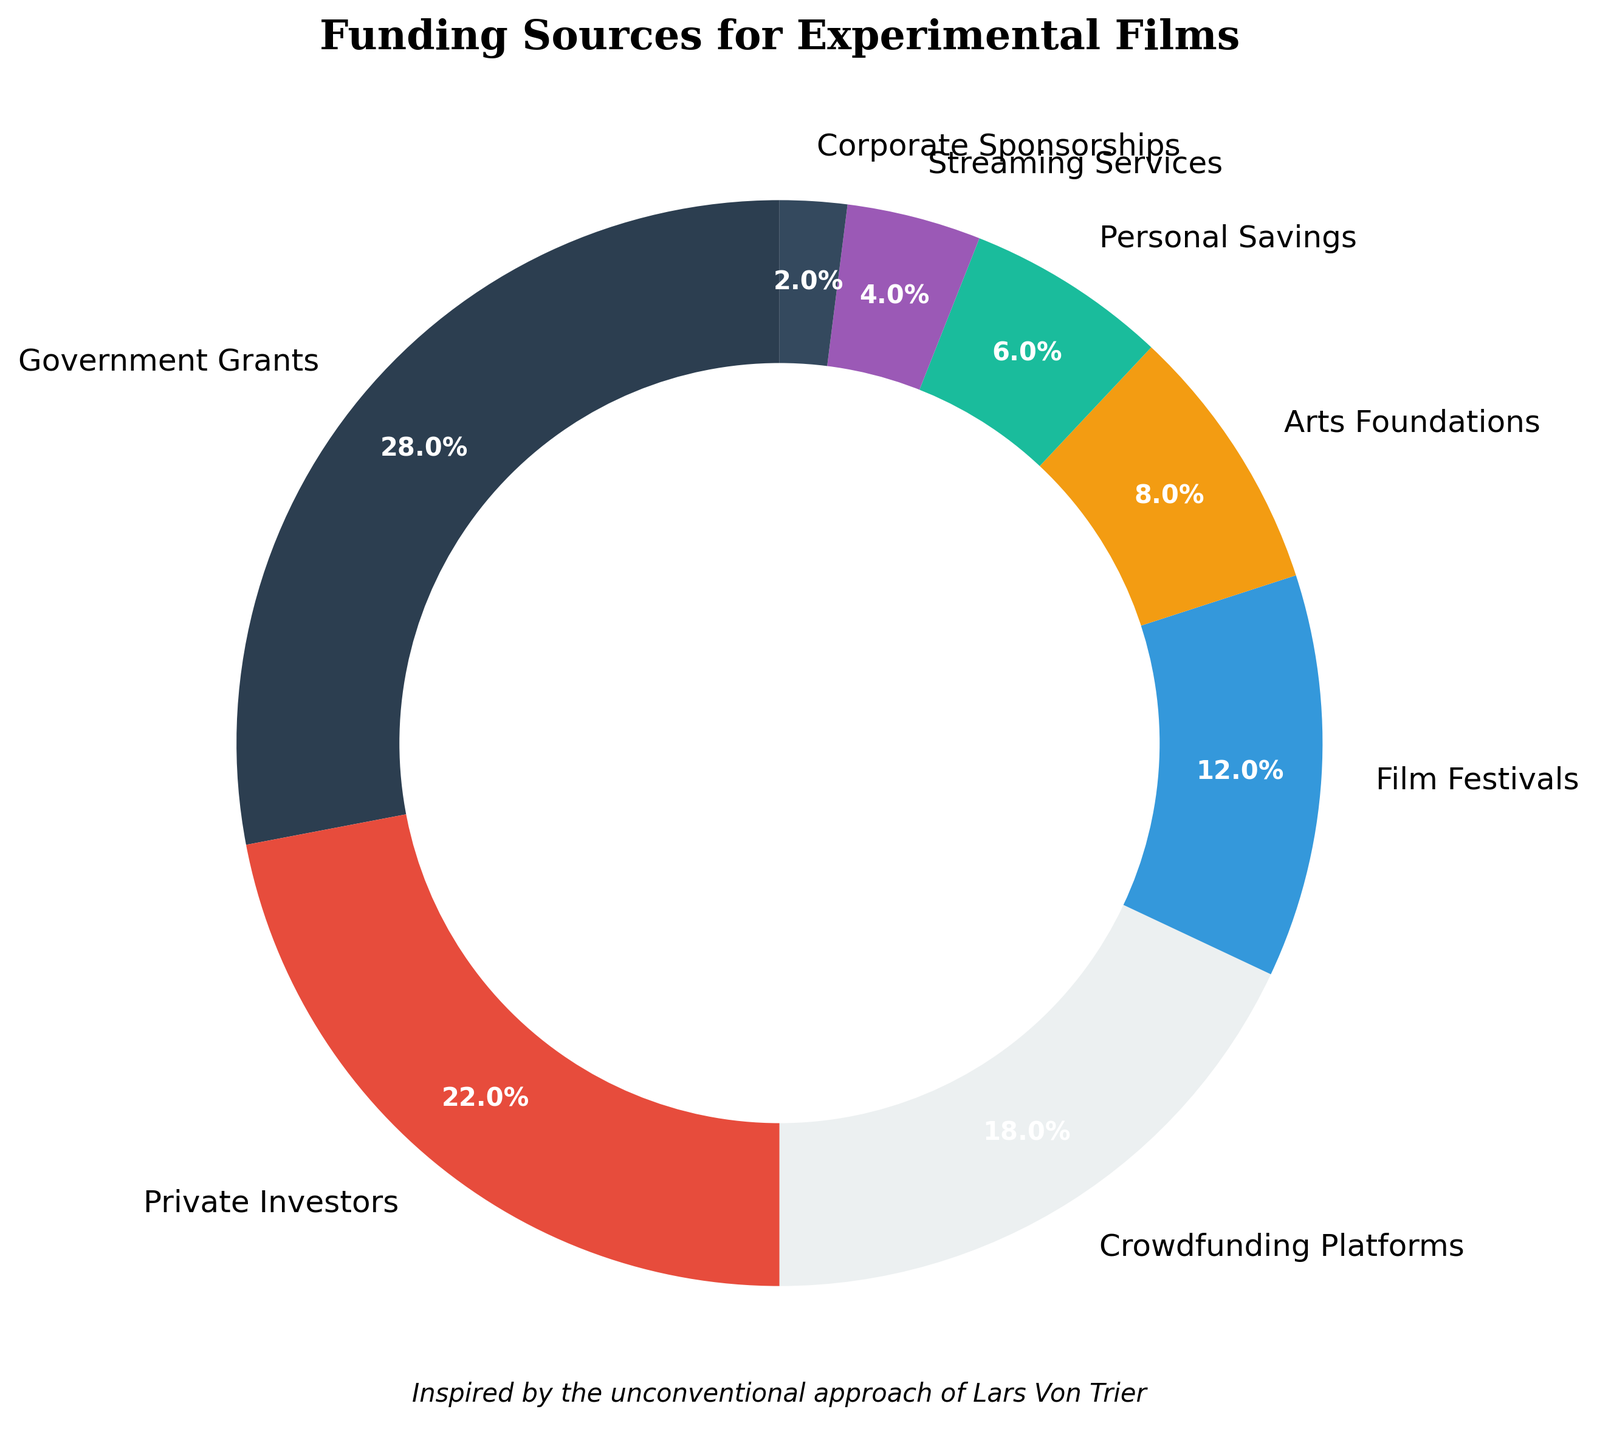What funding source has the highest percentage? The wedge of the pie chart representing Government Grants is the largest, which indicates it has the highest percentage.
Answer: Government Grants Which two funding sources have the closest percentages? By visually comparing the sizes of the wedges, Private Investors and Crowdfunding Platforms appear to have similar sized sections of the pie chart.
Answer: Private Investors and Crowdfunding Platforms How much funding comes from sources providing less than 10% each? Adding the percentages of Arts Foundations, Personal Savings, Streaming Services, and Corporate Sponsorships: 8% + 6% + 4% + 2% = 20%.
Answer: 20% What is the combined percentage of funding from Crowdfunding Platforms and Film Festivals? Adding the percentages of Crowdfunding Platforms and Film Festivals: 18% + 12% = 30%.
Answer: 30% Are Government Grants and Corporate Sponsorships funding sources equal? The wedge for Government Grants is much larger than the wedge for Corporate Sponsorships. Government Grants represent a significant portion at 28%, while Corporate Sponsorships is only at 2%, showing they are not equal.
Answer: No What color represents Private Investors? The wedge representing Private Investors is colored red.
Answer: Red Is funding from Arts Foundations more or less than from Personal Savings? The wedge for Arts Foundations is larger than the wedge for Personal Savings. Arts Foundations have 8%, which is more than the 6% from Personal Savings.
Answer: More What percentage of the funding comes from sources providing more than 20% each? Adding the percentages of Government Grants and Private Investors: 28% + 22% = 50%.
Answer: 50% What is the difference in funding percentages between Crowdfunding Platforms and Corporate Sponsorships? Subtracting the percentage of Corporate Sponsorships from Crowdfunding Platforms: 18% - 2% = 16%.
Answer: 16% Which funding sources contribute more than 10% each to the funding? Looking at the sections of the pie chart: Government Grants (28%), Private Investors (22%), Crowdfunding Platforms (18%), and Film Festivals (12%) each contribute more than 10%.
Answer: Government Grants, Private Investors, Crowdfunding Platforms, and Film Festivals 